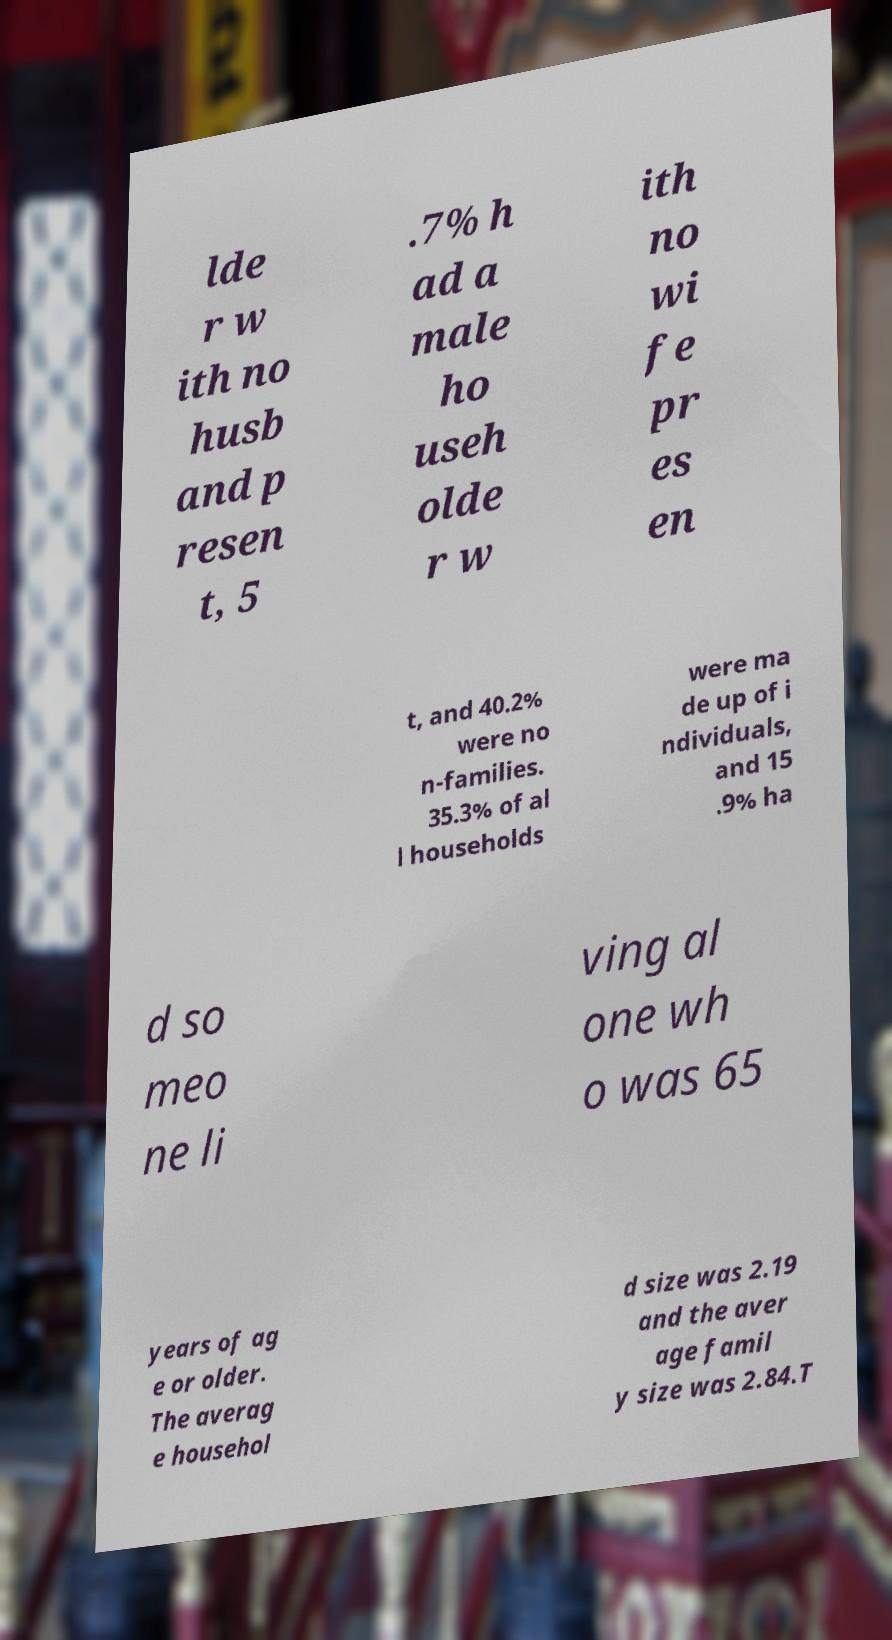Could you assist in decoding the text presented in this image and type it out clearly? lde r w ith no husb and p resen t, 5 .7% h ad a male ho useh olde r w ith no wi fe pr es en t, and 40.2% were no n-families. 35.3% of al l households were ma de up of i ndividuals, and 15 .9% ha d so meo ne li ving al one wh o was 65 years of ag e or older. The averag e househol d size was 2.19 and the aver age famil y size was 2.84.T 